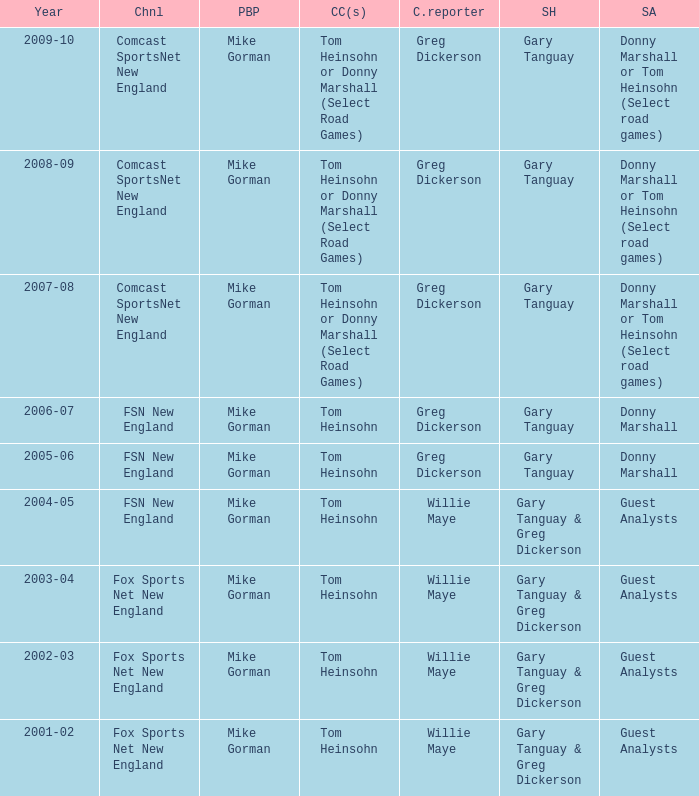Who are the studio analysts for the year 2008-09? Donny Marshall or Tom Heinsohn (Select road games). 